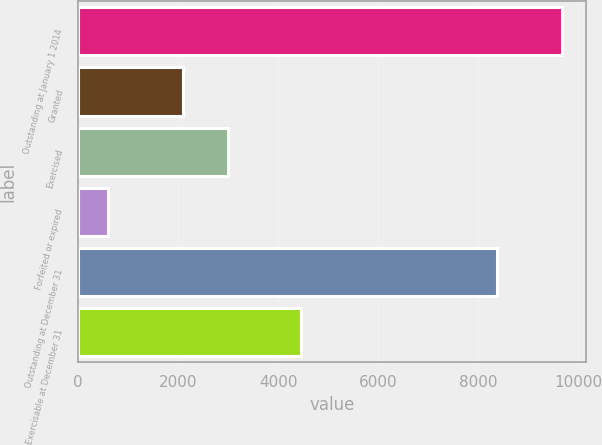Convert chart to OTSL. <chart><loc_0><loc_0><loc_500><loc_500><bar_chart><fcel>Outstanding at January 1 2014<fcel>Granted<fcel>Exercised<fcel>Forfeited or expired<fcel>Outstanding at December 31<fcel>Exercisable at December 31<nl><fcel>9674<fcel>2099<fcel>3006.7<fcel>597<fcel>8378<fcel>4451<nl></chart> 